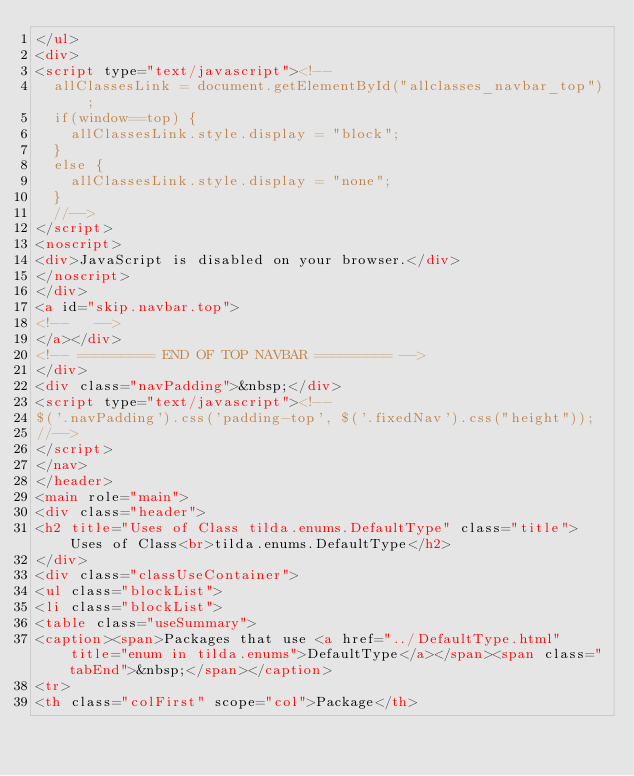<code> <loc_0><loc_0><loc_500><loc_500><_HTML_></ul>
<div>
<script type="text/javascript"><!--
  allClassesLink = document.getElementById("allclasses_navbar_top");
  if(window==top) {
    allClassesLink.style.display = "block";
  }
  else {
    allClassesLink.style.display = "none";
  }
  //-->
</script>
<noscript>
<div>JavaScript is disabled on your browser.</div>
</noscript>
</div>
<a id="skip.navbar.top">
<!--   -->
</a></div>
<!-- ========= END OF TOP NAVBAR ========= -->
</div>
<div class="navPadding">&nbsp;</div>
<script type="text/javascript"><!--
$('.navPadding').css('padding-top', $('.fixedNav').css("height"));
//-->
</script>
</nav>
</header>
<main role="main">
<div class="header">
<h2 title="Uses of Class tilda.enums.DefaultType" class="title">Uses of Class<br>tilda.enums.DefaultType</h2>
</div>
<div class="classUseContainer">
<ul class="blockList">
<li class="blockList">
<table class="useSummary">
<caption><span>Packages that use <a href="../DefaultType.html" title="enum in tilda.enums">DefaultType</a></span><span class="tabEnd">&nbsp;</span></caption>
<tr>
<th class="colFirst" scope="col">Package</th></code> 